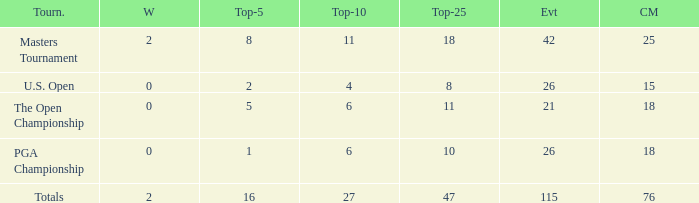What is the total of wins when the cuts made is 76 and the events greater than 115? None. 